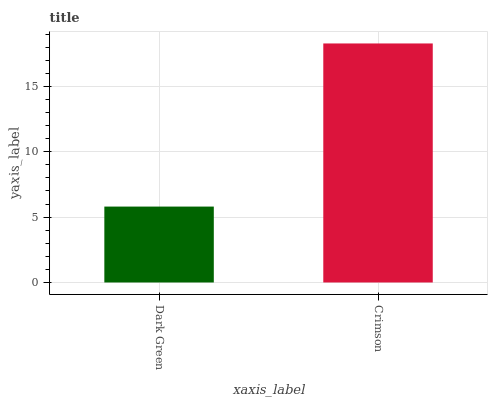Is Dark Green the minimum?
Answer yes or no. Yes. Is Crimson the maximum?
Answer yes or no. Yes. Is Crimson the minimum?
Answer yes or no. No. Is Crimson greater than Dark Green?
Answer yes or no. Yes. Is Dark Green less than Crimson?
Answer yes or no. Yes. Is Dark Green greater than Crimson?
Answer yes or no. No. Is Crimson less than Dark Green?
Answer yes or no. No. Is Crimson the high median?
Answer yes or no. Yes. Is Dark Green the low median?
Answer yes or no. Yes. Is Dark Green the high median?
Answer yes or no. No. Is Crimson the low median?
Answer yes or no. No. 